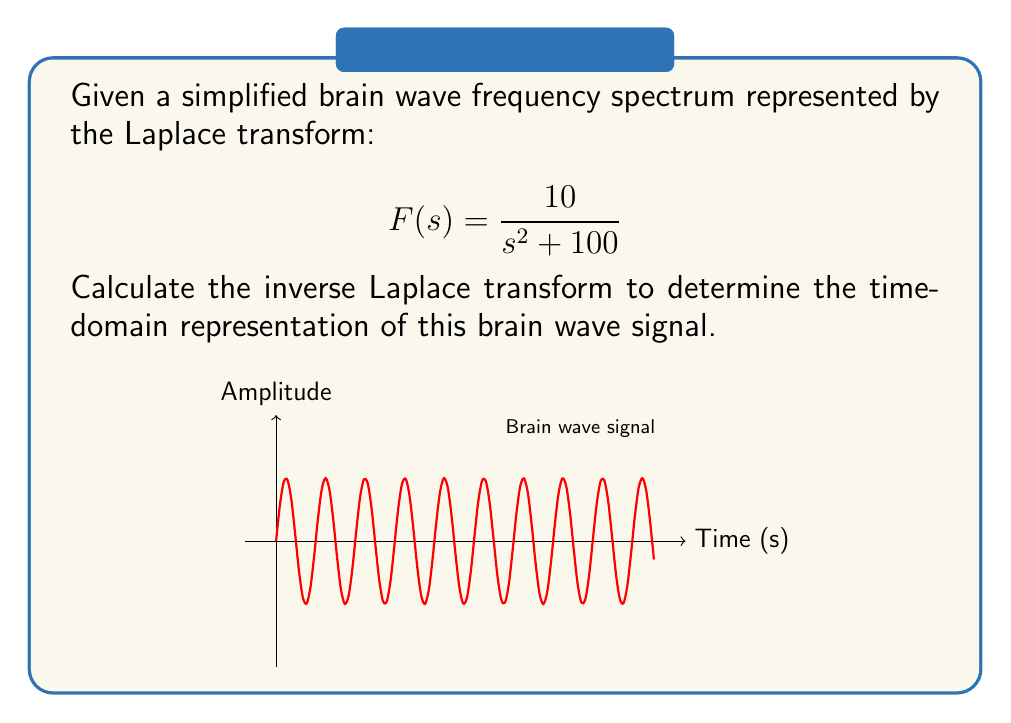What is the answer to this math problem? To find the inverse Laplace transform, we follow these steps:

1) Recognize the form of the given Laplace transform:
   $$F(s) = \frac{10}{s^2 + 100}$$

2) This form matches the standard Laplace transform pair:
   $$\mathcal{L}\{A\sin(\omega t)\} = \frac{A\omega}{s^2 + \omega^2}$$

3) In our case:
   $A\omega = 10$
   $\omega^2 = 100$

4) Solve for $A$ and $\omega$:
   $\omega = \sqrt{100} = 10$
   $A = \frac{10}{\omega} = \frac{10}{10} = 1$

5) Therefore, the inverse Laplace transform is:
   $$f(t) = \sin(10t)$$

6) Multiply by the amplitude $A$:
   $$f(t) = 1 \cdot \sin(10t) = \sin(10t)$$

Thus, the time-domain representation of the brain wave signal is $\sin(10t)$.
Answer: $f(t) = \sin(10t)$ 